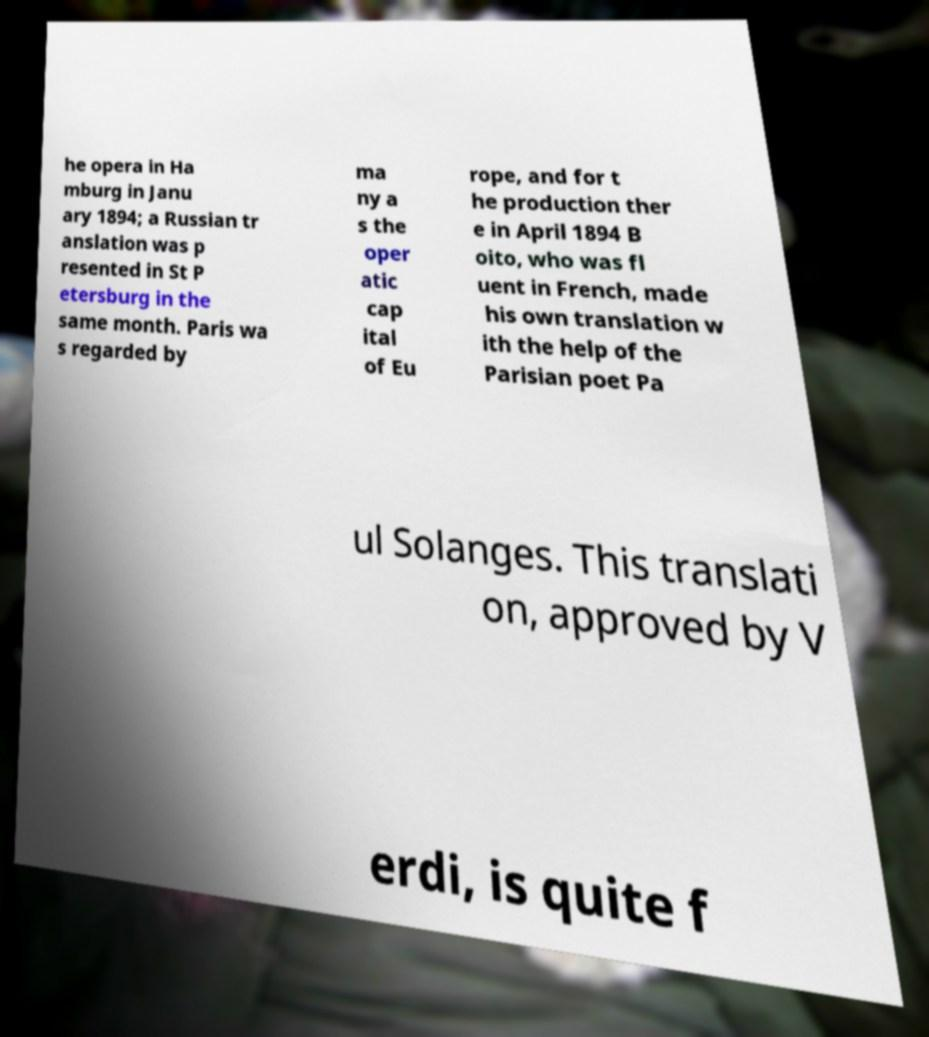Please read and relay the text visible in this image. What does it say? he opera in Ha mburg in Janu ary 1894; a Russian tr anslation was p resented in St P etersburg in the same month. Paris wa s regarded by ma ny a s the oper atic cap ital of Eu rope, and for t he production ther e in April 1894 B oito, who was fl uent in French, made his own translation w ith the help of the Parisian poet Pa ul Solanges. This translati on, approved by V erdi, is quite f 